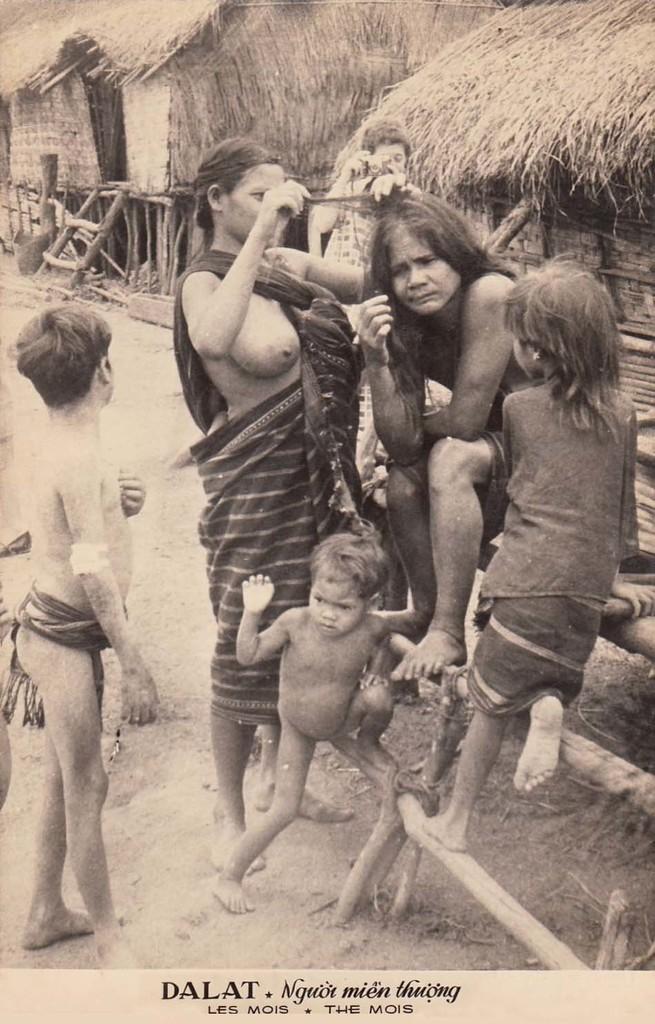Please provide a concise description of this image. This is a black and white image. Here I can see a woman and few children. In the background there are two huts. At the bottom of this image I can see the text. 